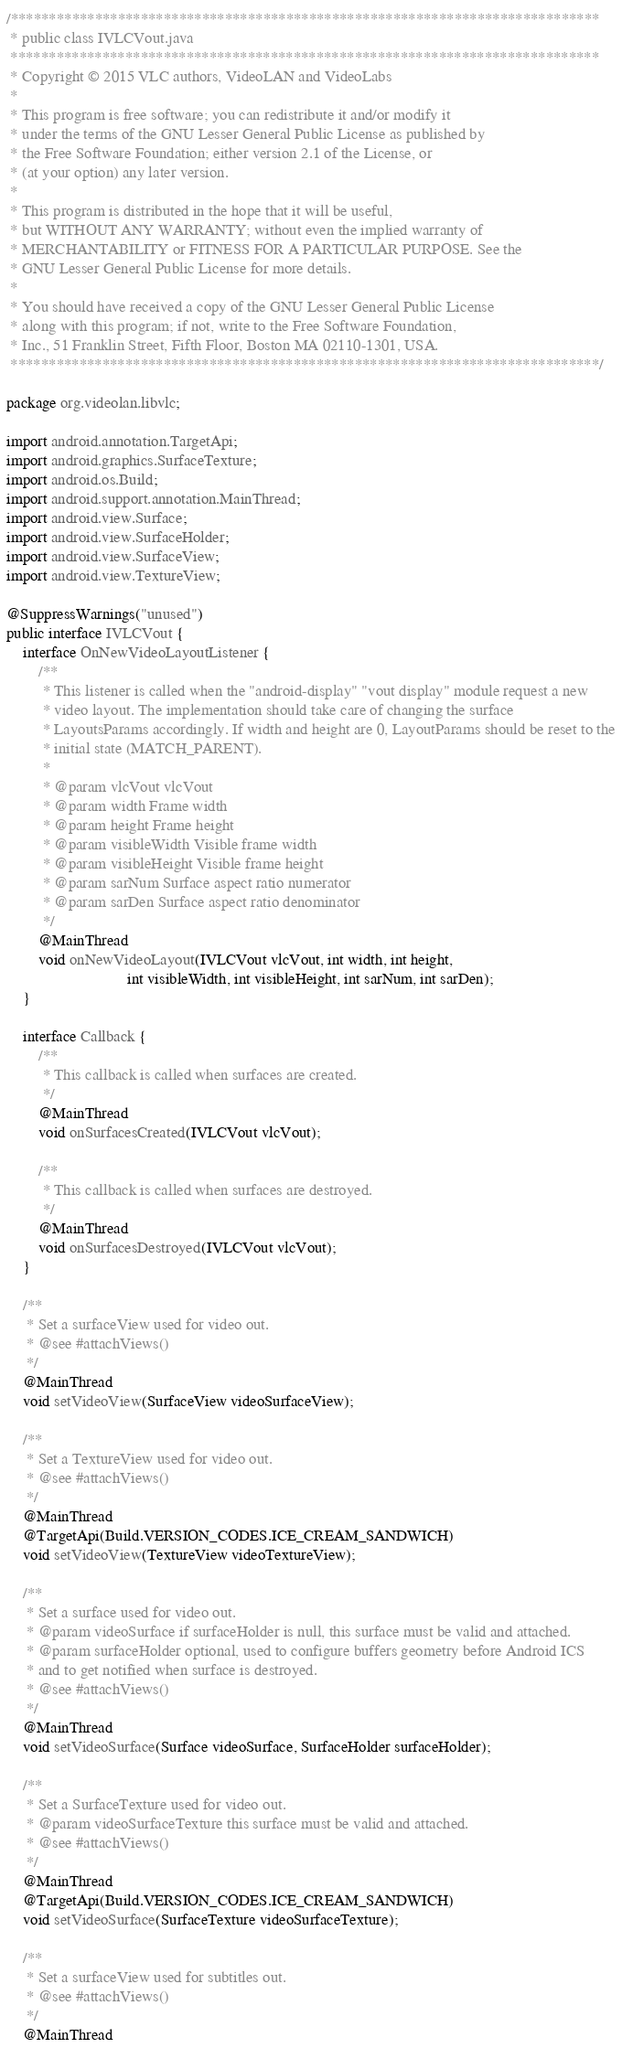Convert code to text. <code><loc_0><loc_0><loc_500><loc_500><_Java_>/*****************************************************************************
 * public class IVLCVout.java
 *****************************************************************************
 * Copyright © 2015 VLC authors, VideoLAN and VideoLabs
 *
 * This program is free software; you can redistribute it and/or modify it
 * under the terms of the GNU Lesser General Public License as published by
 * the Free Software Foundation; either version 2.1 of the License, or
 * (at your option) any later version.
 *
 * This program is distributed in the hope that it will be useful,
 * but WITHOUT ANY WARRANTY; without even the implied warranty of
 * MERCHANTABILITY or FITNESS FOR A PARTICULAR PURPOSE. See the
 * GNU Lesser General Public License for more details.
 *
 * You should have received a copy of the GNU Lesser General Public License
 * along with this program; if not, write to the Free Software Foundation,
 * Inc., 51 Franklin Street, Fifth Floor, Boston MA 02110-1301, USA.
 *****************************************************************************/

package org.videolan.libvlc;

import android.annotation.TargetApi;
import android.graphics.SurfaceTexture;
import android.os.Build;
import android.support.annotation.MainThread;
import android.view.Surface;
import android.view.SurfaceHolder;
import android.view.SurfaceView;
import android.view.TextureView;

@SuppressWarnings("unused")
public interface IVLCVout {
    interface OnNewVideoLayoutListener {
        /**
         * This listener is called when the "android-display" "vout display" module request a new
         * video layout. The implementation should take care of changing the surface
         * LayoutsParams accordingly. If width and height are 0, LayoutParams should be reset to the
         * initial state (MATCH_PARENT).
         *
         * @param vlcVout vlcVout
         * @param width Frame width
         * @param height Frame height
         * @param visibleWidth Visible frame width
         * @param visibleHeight Visible frame height
         * @param sarNum Surface aspect ratio numerator
         * @param sarDen Surface aspect ratio denominator
         */
        @MainThread
        void onNewVideoLayout(IVLCVout vlcVout, int width, int height,
                              int visibleWidth, int visibleHeight, int sarNum, int sarDen);
    }

    interface Callback {
        /**
         * This callback is called when surfaces are created.
         */
        @MainThread
        void onSurfacesCreated(IVLCVout vlcVout);

        /**
         * This callback is called when surfaces are destroyed.
         */
        @MainThread
        void onSurfacesDestroyed(IVLCVout vlcVout);
    }

    /**
     * Set a surfaceView used for video out.
     * @see #attachViews()
     */
    @MainThread
    void setVideoView(SurfaceView videoSurfaceView);

    /**
     * Set a TextureView used for video out.
     * @see #attachViews()
     */
    @MainThread
    @TargetApi(Build.VERSION_CODES.ICE_CREAM_SANDWICH)
    void setVideoView(TextureView videoTextureView);

    /**
     * Set a surface used for video out.
     * @param videoSurface if surfaceHolder is null, this surface must be valid and attached.
     * @param surfaceHolder optional, used to configure buffers geometry before Android ICS
     * and to get notified when surface is destroyed.
     * @see #attachViews()
     */
    @MainThread
    void setVideoSurface(Surface videoSurface, SurfaceHolder surfaceHolder);

    /**
     * Set a SurfaceTexture used for video out.
     * @param videoSurfaceTexture this surface must be valid and attached.
     * @see #attachViews()
     */
    @MainThread
    @TargetApi(Build.VERSION_CODES.ICE_CREAM_SANDWICH)
    void setVideoSurface(SurfaceTexture videoSurfaceTexture);

    /**
     * Set a surfaceView used for subtitles out.
     * @see #attachViews()
     */
    @MainThread</code> 